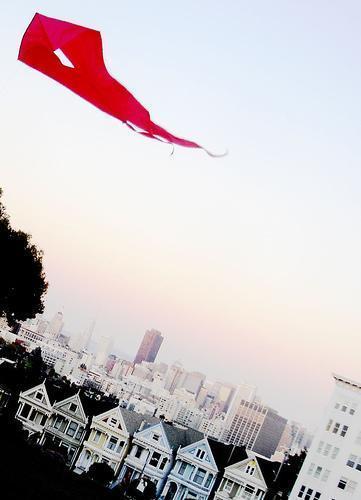How many kites can be seen?
Give a very brief answer. 1. How many boats are in the water?
Give a very brief answer. 0. 